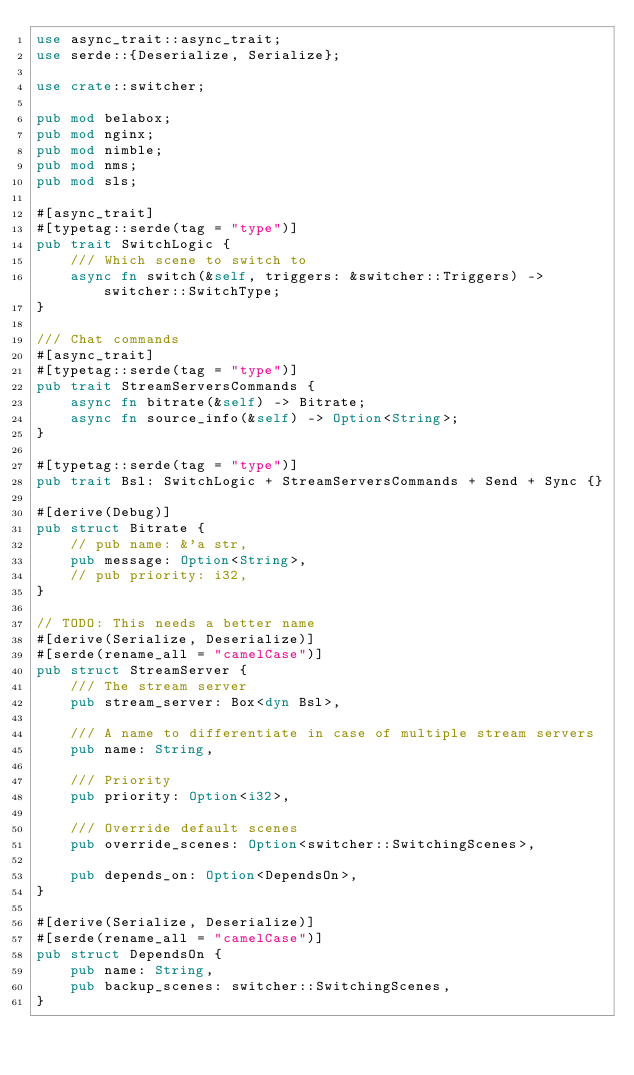<code> <loc_0><loc_0><loc_500><loc_500><_Rust_>use async_trait::async_trait;
use serde::{Deserialize, Serialize};

use crate::switcher;

pub mod belabox;
pub mod nginx;
pub mod nimble;
pub mod nms;
pub mod sls;

#[async_trait]
#[typetag::serde(tag = "type")]
pub trait SwitchLogic {
    /// Which scene to switch to
    async fn switch(&self, triggers: &switcher::Triggers) -> switcher::SwitchType;
}

/// Chat commands
#[async_trait]
#[typetag::serde(tag = "type")]
pub trait StreamServersCommands {
    async fn bitrate(&self) -> Bitrate;
    async fn source_info(&self) -> Option<String>;
}

#[typetag::serde(tag = "type")]
pub trait Bsl: SwitchLogic + StreamServersCommands + Send + Sync {}

#[derive(Debug)]
pub struct Bitrate {
    // pub name: &'a str,
    pub message: Option<String>,
    // pub priority: i32,
}

// TODO: This needs a better name
#[derive(Serialize, Deserialize)]
#[serde(rename_all = "camelCase")]
pub struct StreamServer {
    /// The stream server
    pub stream_server: Box<dyn Bsl>,

    /// A name to differentiate in case of multiple stream servers
    pub name: String,

    /// Priority
    pub priority: Option<i32>,

    /// Override default scenes
    pub override_scenes: Option<switcher::SwitchingScenes>,

    pub depends_on: Option<DependsOn>,
}

#[derive(Serialize, Deserialize)]
#[serde(rename_all = "camelCase")]
pub struct DependsOn {
    pub name: String,
    pub backup_scenes: switcher::SwitchingScenes,
}
</code> 